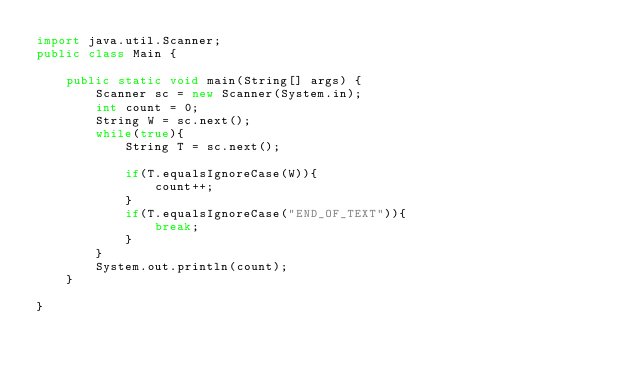Convert code to text. <code><loc_0><loc_0><loc_500><loc_500><_Java_>import java.util.Scanner;
public class Main {

    public static void main(String[] args) {
        Scanner sc = new Scanner(System.in);
        int count = 0;
        String W = sc.next();
        while(true){
            String T = sc.next();

            if(T.equalsIgnoreCase(W)){
                count++;
            }
            if(T.equalsIgnoreCase("END_OF_TEXT")){
                break;
            }
        }
        System.out.println(count);
    }

}
</code> 